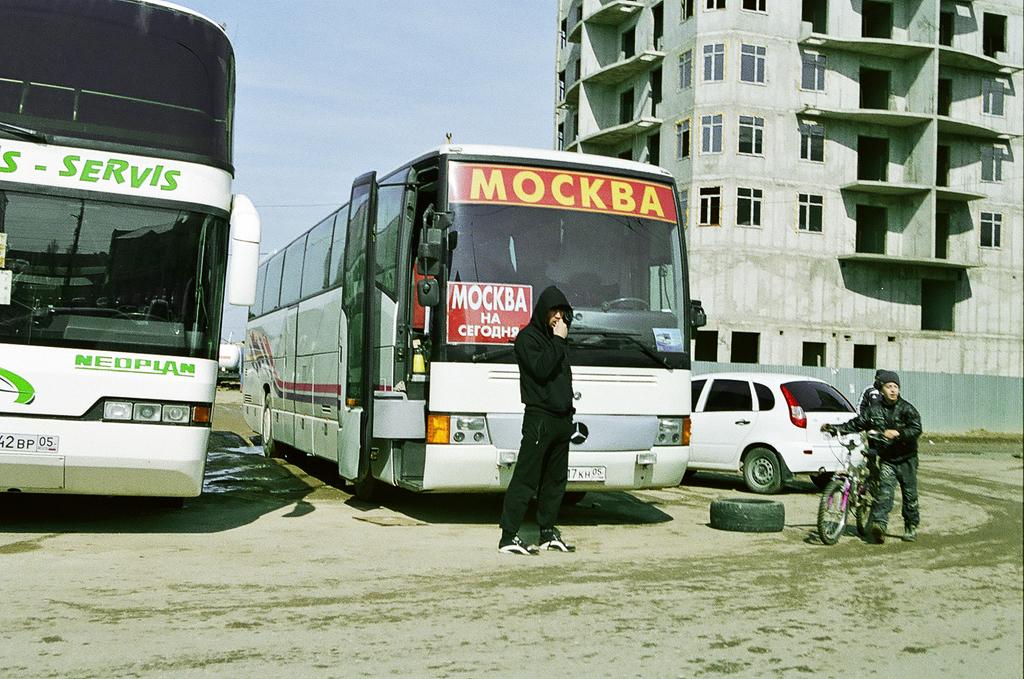What company operates the bus on the right?
Your answer should be very brief. Mockba. What is the word in green at the top of the bus on the left?
Provide a succinct answer. Servis. 